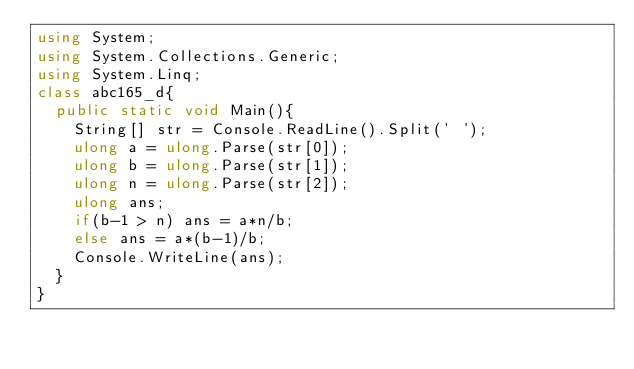Convert code to text. <code><loc_0><loc_0><loc_500><loc_500><_C#_>using System;
using System.Collections.Generic;
using System.Linq;
class abc165_d{
  public static void Main(){
    String[] str = Console.ReadLine().Split(' ');
    ulong a = ulong.Parse(str[0]);
    ulong b = ulong.Parse(str[1]);
    ulong n = ulong.Parse(str[2]);
    ulong ans;
    if(b-1 > n) ans = a*n/b;
    else ans = a*(b-1)/b;
    Console.WriteLine(ans);
  }
}
</code> 